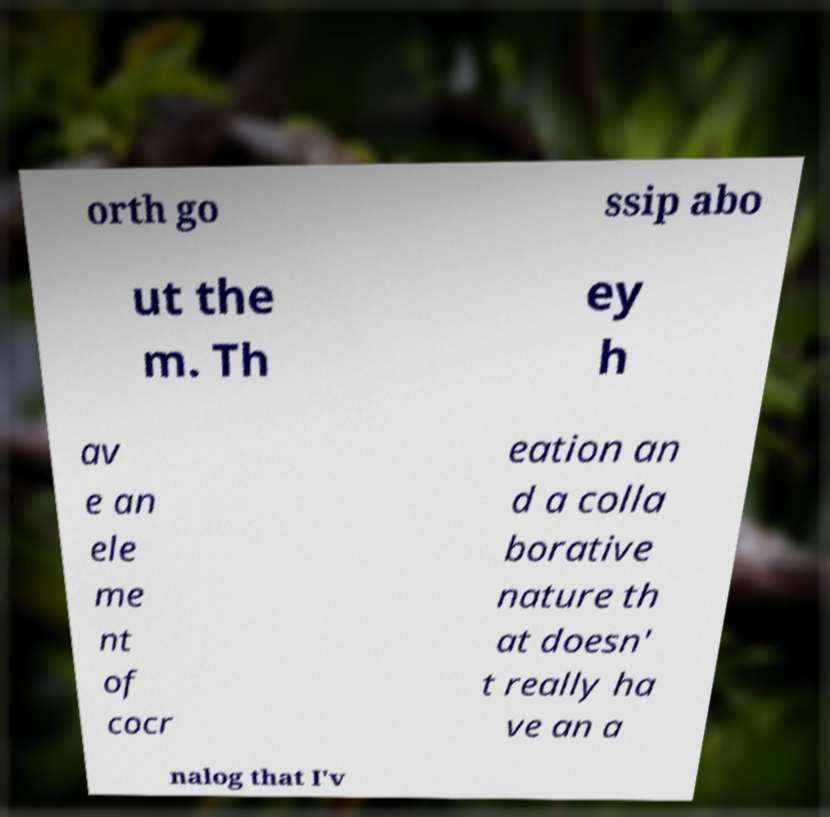What messages or text are displayed in this image? I need them in a readable, typed format. orth go ssip abo ut the m. Th ey h av e an ele me nt of cocr eation an d a colla borative nature th at doesn' t really ha ve an a nalog that I'v 